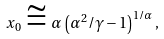Convert formula to latex. <formula><loc_0><loc_0><loc_500><loc_500>x _ { 0 } \cong \alpha \, \left ( \alpha ^ { 2 } / \gamma - 1 \right ) ^ { 1 / \alpha } ,</formula> 